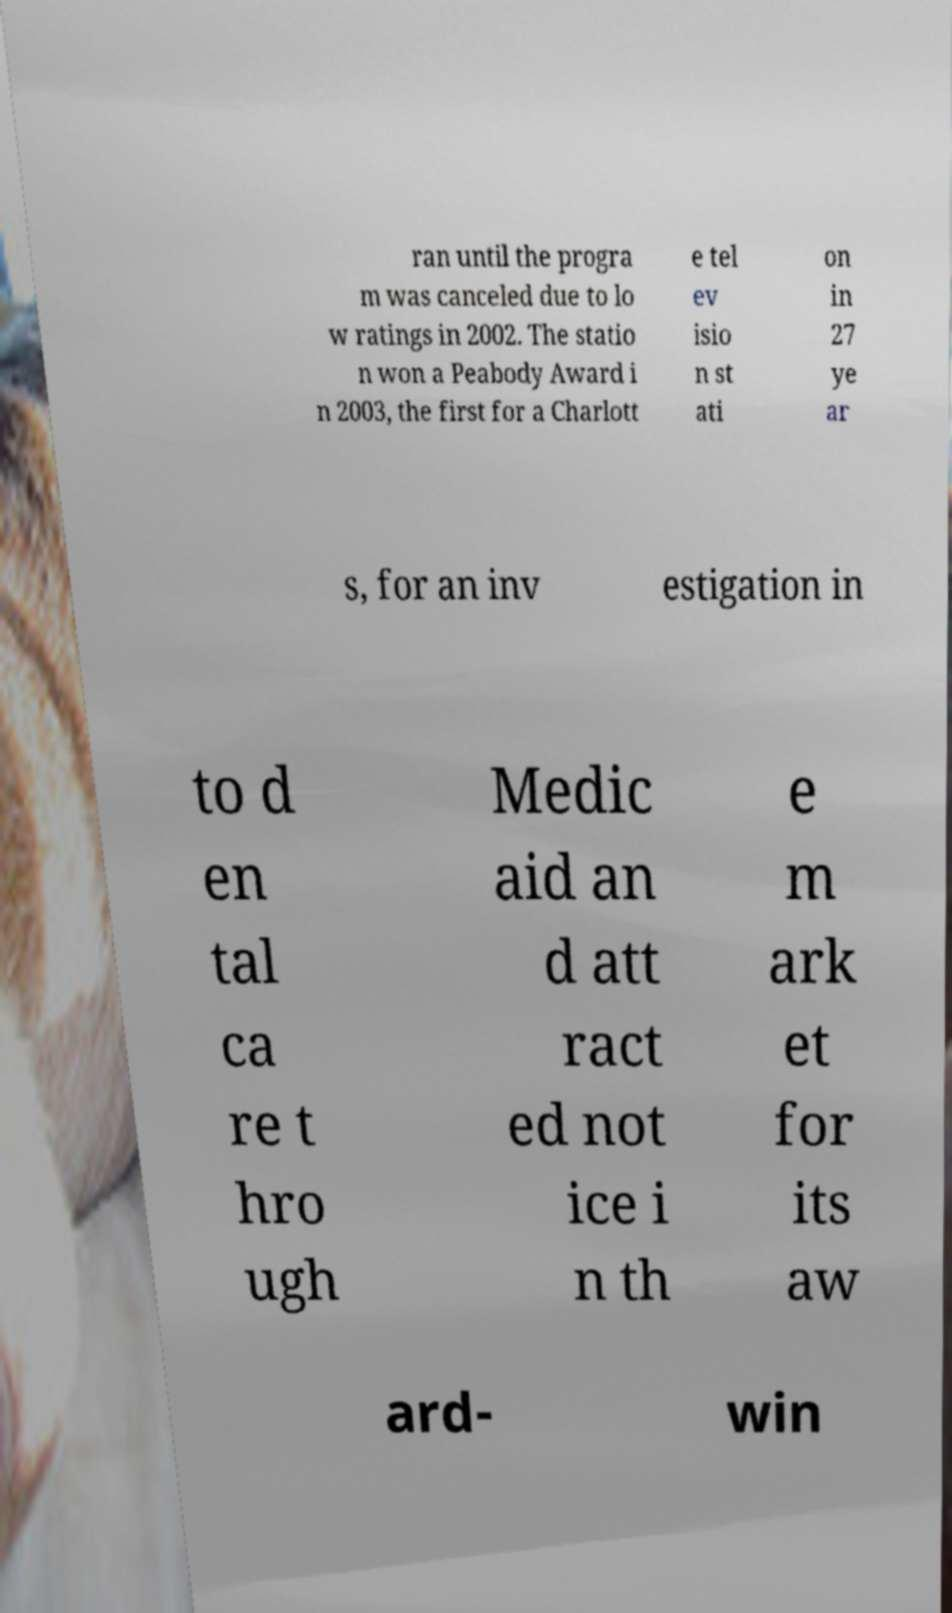Please identify and transcribe the text found in this image. ran until the progra m was canceled due to lo w ratings in 2002. The statio n won a Peabody Award i n 2003, the first for a Charlott e tel ev isio n st ati on in 27 ye ar s, for an inv estigation in to d en tal ca re t hro ugh Medic aid an d att ract ed not ice i n th e m ark et for its aw ard- win 